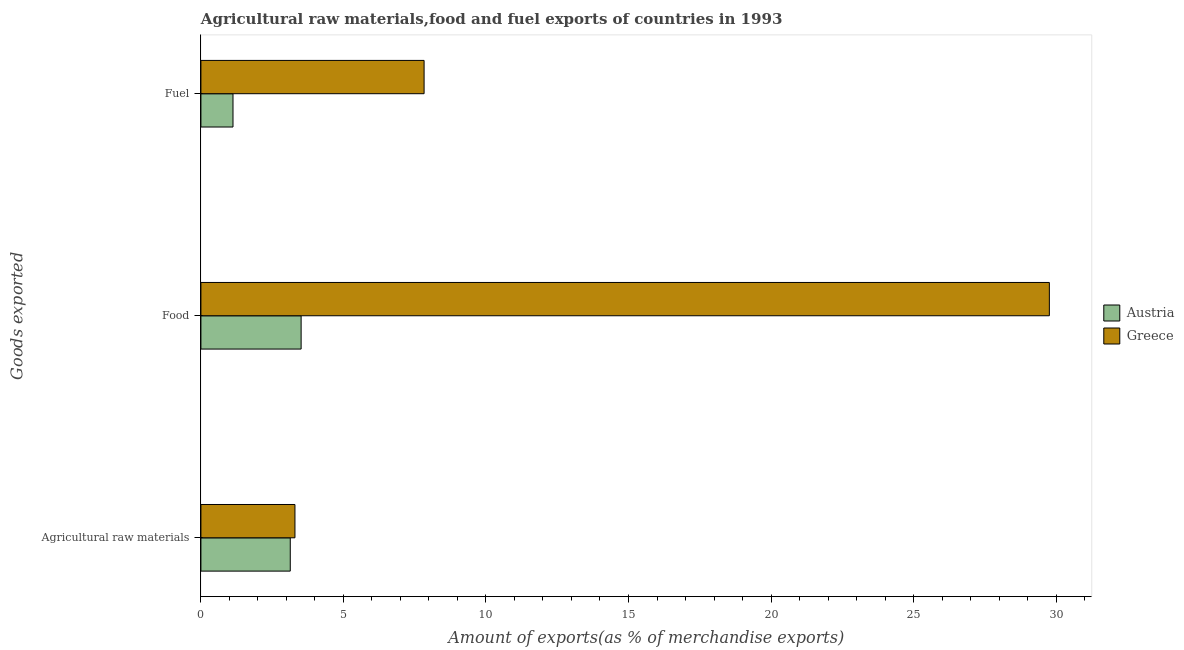How many different coloured bars are there?
Keep it short and to the point. 2. What is the label of the 1st group of bars from the top?
Ensure brevity in your answer.  Fuel. What is the percentage of raw materials exports in Greece?
Your response must be concise. 3.3. Across all countries, what is the maximum percentage of food exports?
Provide a short and direct response. 29.76. Across all countries, what is the minimum percentage of raw materials exports?
Ensure brevity in your answer.  3.13. In which country was the percentage of fuel exports minimum?
Provide a short and direct response. Austria. What is the total percentage of food exports in the graph?
Keep it short and to the point. 33.28. What is the difference between the percentage of raw materials exports in Austria and that in Greece?
Give a very brief answer. -0.16. What is the difference between the percentage of food exports in Austria and the percentage of raw materials exports in Greece?
Keep it short and to the point. 0.22. What is the average percentage of food exports per country?
Keep it short and to the point. 16.64. What is the difference between the percentage of food exports and percentage of fuel exports in Greece?
Offer a terse response. 21.93. In how many countries, is the percentage of fuel exports greater than 18 %?
Your response must be concise. 0. What is the ratio of the percentage of food exports in Austria to that in Greece?
Offer a very short reply. 0.12. Is the difference between the percentage of food exports in Austria and Greece greater than the difference between the percentage of raw materials exports in Austria and Greece?
Provide a short and direct response. No. What is the difference between the highest and the second highest percentage of fuel exports?
Ensure brevity in your answer.  6.7. What is the difference between the highest and the lowest percentage of fuel exports?
Your answer should be very brief. 6.7. What does the 2nd bar from the top in Food represents?
Offer a very short reply. Austria. Is it the case that in every country, the sum of the percentage of raw materials exports and percentage of food exports is greater than the percentage of fuel exports?
Ensure brevity in your answer.  Yes. How many bars are there?
Offer a very short reply. 6. Are all the bars in the graph horizontal?
Your response must be concise. Yes. What is the difference between two consecutive major ticks on the X-axis?
Ensure brevity in your answer.  5. Are the values on the major ticks of X-axis written in scientific E-notation?
Keep it short and to the point. No. Where does the legend appear in the graph?
Ensure brevity in your answer.  Center right. How many legend labels are there?
Ensure brevity in your answer.  2. What is the title of the graph?
Provide a succinct answer. Agricultural raw materials,food and fuel exports of countries in 1993. Does "Tonga" appear as one of the legend labels in the graph?
Provide a short and direct response. No. What is the label or title of the X-axis?
Make the answer very short. Amount of exports(as % of merchandise exports). What is the label or title of the Y-axis?
Keep it short and to the point. Goods exported. What is the Amount of exports(as % of merchandise exports) in Austria in Agricultural raw materials?
Give a very brief answer. 3.13. What is the Amount of exports(as % of merchandise exports) in Greece in Agricultural raw materials?
Make the answer very short. 3.3. What is the Amount of exports(as % of merchandise exports) of Austria in Food?
Your answer should be compact. 3.52. What is the Amount of exports(as % of merchandise exports) in Greece in Food?
Make the answer very short. 29.76. What is the Amount of exports(as % of merchandise exports) of Austria in Fuel?
Keep it short and to the point. 1.13. What is the Amount of exports(as % of merchandise exports) in Greece in Fuel?
Your answer should be very brief. 7.83. Across all Goods exported, what is the maximum Amount of exports(as % of merchandise exports) of Austria?
Your response must be concise. 3.52. Across all Goods exported, what is the maximum Amount of exports(as % of merchandise exports) in Greece?
Keep it short and to the point. 29.76. Across all Goods exported, what is the minimum Amount of exports(as % of merchandise exports) in Austria?
Give a very brief answer. 1.13. Across all Goods exported, what is the minimum Amount of exports(as % of merchandise exports) of Greece?
Ensure brevity in your answer.  3.3. What is the total Amount of exports(as % of merchandise exports) of Austria in the graph?
Provide a short and direct response. 7.78. What is the total Amount of exports(as % of merchandise exports) in Greece in the graph?
Offer a terse response. 40.89. What is the difference between the Amount of exports(as % of merchandise exports) in Austria in Agricultural raw materials and that in Food?
Make the answer very short. -0.38. What is the difference between the Amount of exports(as % of merchandise exports) of Greece in Agricultural raw materials and that in Food?
Keep it short and to the point. -26.47. What is the difference between the Amount of exports(as % of merchandise exports) of Austria in Agricultural raw materials and that in Fuel?
Give a very brief answer. 2.01. What is the difference between the Amount of exports(as % of merchandise exports) in Greece in Agricultural raw materials and that in Fuel?
Your answer should be compact. -4.53. What is the difference between the Amount of exports(as % of merchandise exports) of Austria in Food and that in Fuel?
Keep it short and to the point. 2.39. What is the difference between the Amount of exports(as % of merchandise exports) of Greece in Food and that in Fuel?
Offer a terse response. 21.93. What is the difference between the Amount of exports(as % of merchandise exports) in Austria in Agricultural raw materials and the Amount of exports(as % of merchandise exports) in Greece in Food?
Make the answer very short. -26.63. What is the difference between the Amount of exports(as % of merchandise exports) in Austria in Agricultural raw materials and the Amount of exports(as % of merchandise exports) in Greece in Fuel?
Make the answer very short. -4.7. What is the difference between the Amount of exports(as % of merchandise exports) of Austria in Food and the Amount of exports(as % of merchandise exports) of Greece in Fuel?
Offer a terse response. -4.31. What is the average Amount of exports(as % of merchandise exports) in Austria per Goods exported?
Provide a short and direct response. 2.59. What is the average Amount of exports(as % of merchandise exports) of Greece per Goods exported?
Give a very brief answer. 13.63. What is the difference between the Amount of exports(as % of merchandise exports) of Austria and Amount of exports(as % of merchandise exports) of Greece in Agricultural raw materials?
Make the answer very short. -0.16. What is the difference between the Amount of exports(as % of merchandise exports) of Austria and Amount of exports(as % of merchandise exports) of Greece in Food?
Provide a succinct answer. -26.25. What is the difference between the Amount of exports(as % of merchandise exports) in Austria and Amount of exports(as % of merchandise exports) in Greece in Fuel?
Provide a succinct answer. -6.7. What is the ratio of the Amount of exports(as % of merchandise exports) of Austria in Agricultural raw materials to that in Food?
Your answer should be compact. 0.89. What is the ratio of the Amount of exports(as % of merchandise exports) in Greece in Agricultural raw materials to that in Food?
Provide a short and direct response. 0.11. What is the ratio of the Amount of exports(as % of merchandise exports) of Austria in Agricultural raw materials to that in Fuel?
Give a very brief answer. 2.78. What is the ratio of the Amount of exports(as % of merchandise exports) in Greece in Agricultural raw materials to that in Fuel?
Provide a succinct answer. 0.42. What is the ratio of the Amount of exports(as % of merchandise exports) of Austria in Food to that in Fuel?
Make the answer very short. 3.12. What is the ratio of the Amount of exports(as % of merchandise exports) of Greece in Food to that in Fuel?
Ensure brevity in your answer.  3.8. What is the difference between the highest and the second highest Amount of exports(as % of merchandise exports) of Austria?
Offer a very short reply. 0.38. What is the difference between the highest and the second highest Amount of exports(as % of merchandise exports) of Greece?
Your answer should be very brief. 21.93. What is the difference between the highest and the lowest Amount of exports(as % of merchandise exports) in Austria?
Offer a very short reply. 2.39. What is the difference between the highest and the lowest Amount of exports(as % of merchandise exports) in Greece?
Your answer should be very brief. 26.47. 